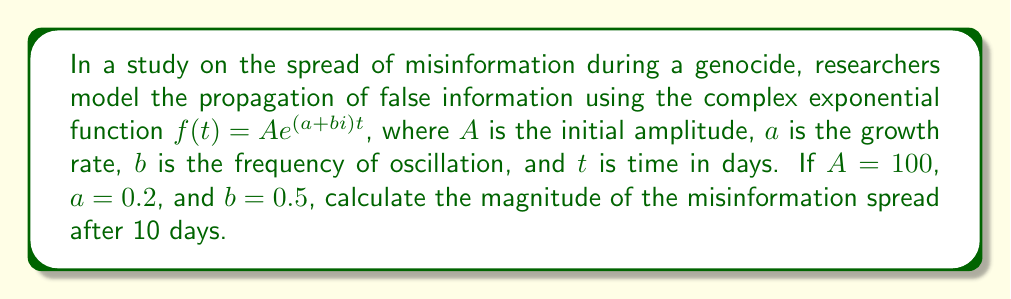Solve this math problem. To solve this problem, we'll follow these steps:

1) The given complex exponential function is:
   $f(t) = Ae^{(a+bi)t}$

2) We're given:
   $A = 100$
   $a = 0.2$
   $b = 0.5$
   $t = 10$

3) Substitute these values into the function:
   $f(10) = 100e^{(0.2+0.5i)10}$

4) Simplify the exponent:
   $f(10) = 100e^{2+5i}$

5) To find the magnitude, we use Euler's formula:
   $e^{x+yi} = e^x(\cos y + i\sin y)$

6) Apply this to our function:
   $f(10) = 100e^2(\cos 5 + i\sin 5)$

7) The magnitude is given by the absolute value:
   $|f(10)| = 100e^2$

8) Calculate this value:
   $|f(10)| = 100 \cdot e^2 \approx 738.91$

Therefore, the magnitude of the misinformation spread after 10 days is approximately 738.91.
Answer: $738.91$ 